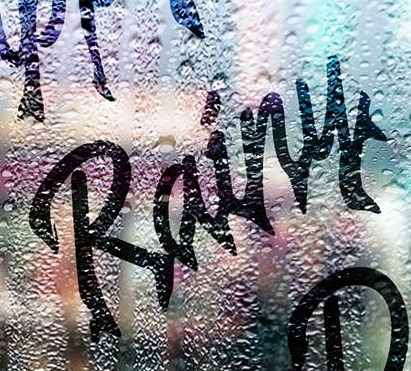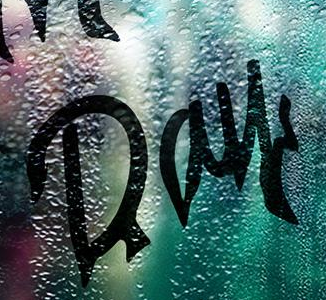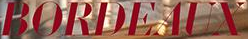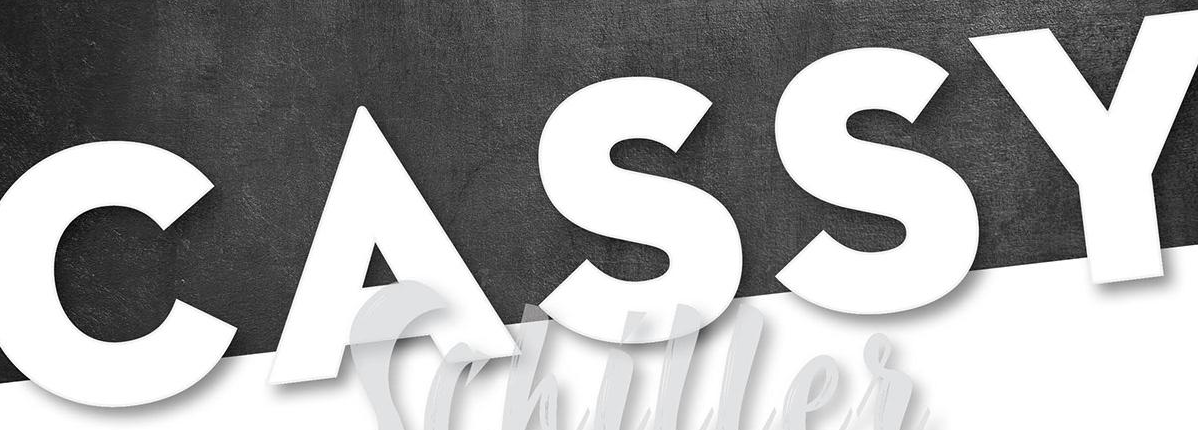Identify the words shown in these images in order, separated by a semicolon. Rainy; Day; BORDEAUX; CASSY 